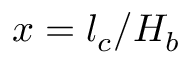Convert formula to latex. <formula><loc_0><loc_0><loc_500><loc_500>x = l _ { c } / H _ { b }</formula> 